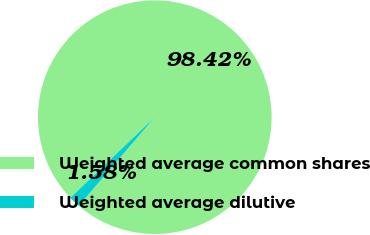Convert chart to OTSL. <chart><loc_0><loc_0><loc_500><loc_500><pie_chart><fcel>Weighted average common shares<fcel>Weighted average dilutive<nl><fcel>98.42%<fcel>1.58%<nl></chart> 